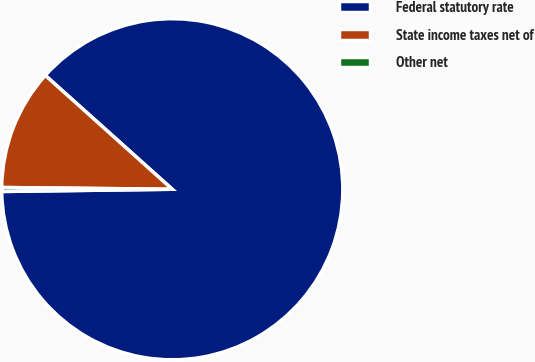Convert chart. <chart><loc_0><loc_0><loc_500><loc_500><pie_chart><fcel>Federal statutory rate<fcel>State income taxes net of<fcel>Other net<nl><fcel>88.16%<fcel>11.47%<fcel>0.37%<nl></chart> 